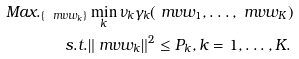<formula> <loc_0><loc_0><loc_500><loc_500>M a x . _ { \{ \ m v { w } _ { k } \} } & \min _ { k } \nu _ { k } \gamma _ { k } ( \ m v { w } _ { 1 } , \dots , \ m v { w } _ { K } ) \\ s . t . & \| \ m v { w } _ { k } \| ^ { 2 } \leq P _ { k } , k = 1 , \dots , K .</formula> 